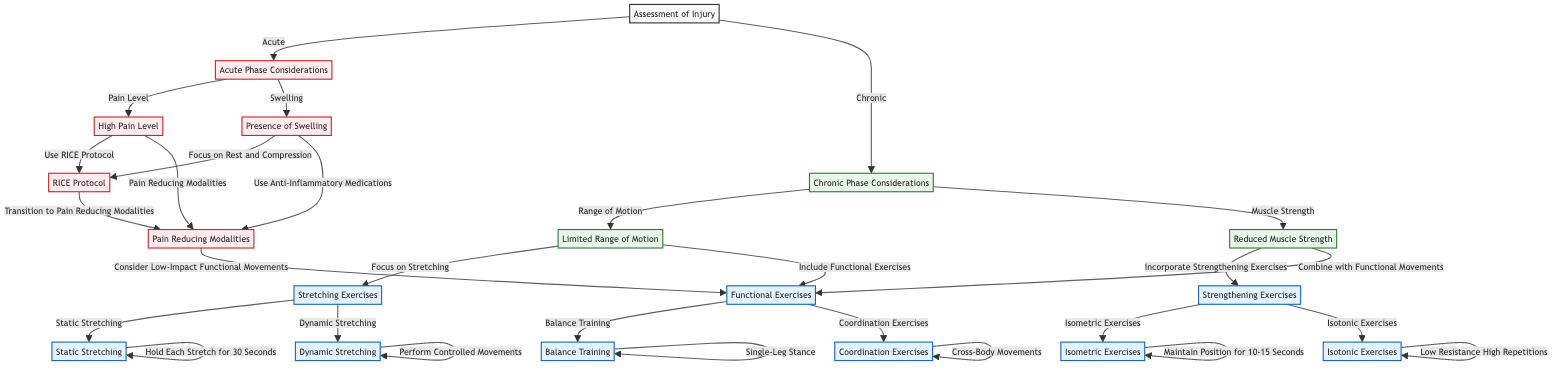What is the first step in the decision-making process? The first node in the decision-making process is "Assessment of Injury," which sets the stage for evaluating the type of injury.
Answer: Assessment of Injury How many choices does the "Acute Phase Considerations" node have? The "Acute Phase Considerations" node has two choices: "Pain Level" and "Swelling." Therefore, the total number of choices it has is two.
Answer: 2 What happens after evaluating "Reduced Muscle Strength"? Evaluating "Reduced Muscle Strength" leads to two options: "Incorporate Strengthening Exercises" and "Combine with Functional Movements." Going through this node allows for both strengthening and functional rehabilitation.
Answer: Incorporate Strengthening Exercises, Combine with Functional Movements What interventions are suggested for "High Pain Level"? The node for "High Pain Level" suggests two interventions: "Use RICE Protocol" and "Pain Reducing Modalities." Each option leads to its specific subsequent step in the decision tree.
Answer: Use RICE Protocol, Pain Reducing Modalities Which type of exercise is recommended if "Limited Range of Motion" is present? The "Limited Range of Motion" node leads to a focus on activities like "Stretching Exercises" and the inclusion of "Functional Exercises." Hence, stretching is a key intervention.
Answer: Stretching Exercises What is the final outcome if "Static Stretching" is chosen? If "Static Stretching" is selected, the final outcome in this node specifies to "Hold Each Stretch for 30 Seconds," outlining the method for performing the exercise correctly.
Answer: Hold Each Stretch for 30 Seconds What is the main intervention recommended when there is "Presence of Swelling"? In the case of "Presence of Swelling," the decision tree prescribes interventions focused on either "Focus on Rest and Compression" or "Use Anti-Inflammatory Medications" to manage swelling effectively.
Answer: Focus on Rest and Compression, Use Anti-Inflammatory Medications What follows after the "Pain Reducing Modalities"? Following "Pain Reducing Modalities," the tree advises considering "Low-Impact Functional Movements," indicating a progression to gradual functional exercises as pain subsides.
Answer: Consider Low-Impact Functional Movements 